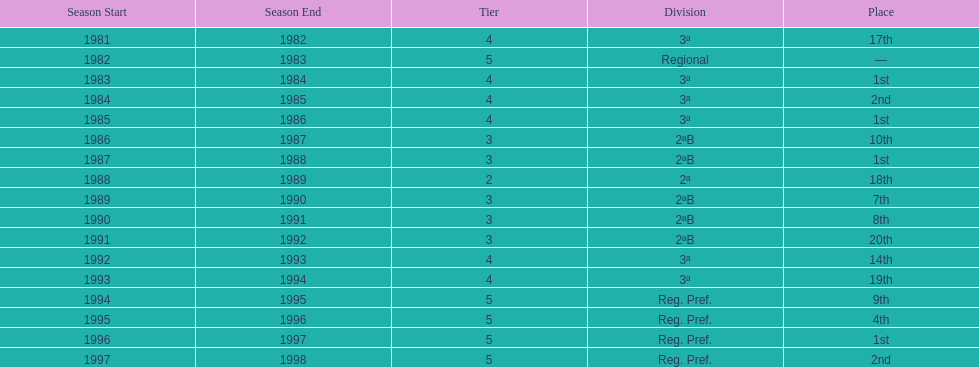How many times total did they finish first 4. 